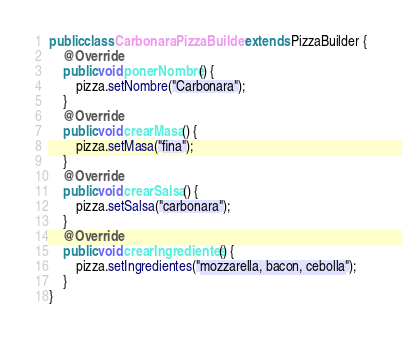Convert code to text. <code><loc_0><loc_0><loc_500><loc_500><_Java_>public class CarbonaraPizzaBuilder extends PizzaBuilder {
    @Override
    public void ponerNombre() {
        pizza.setNombre("Carbonara");
    }
    @Override
    public void crearMasa() {
        pizza.setMasa("fina");
    }
    @Override
    public void crearSalsa() {
        pizza.setSalsa("carbonara");
    }
    @Override
    public void crearIngredientes() {
        pizza.setIngredientes("mozzarella, bacon, cebolla");
    }
}
</code> 